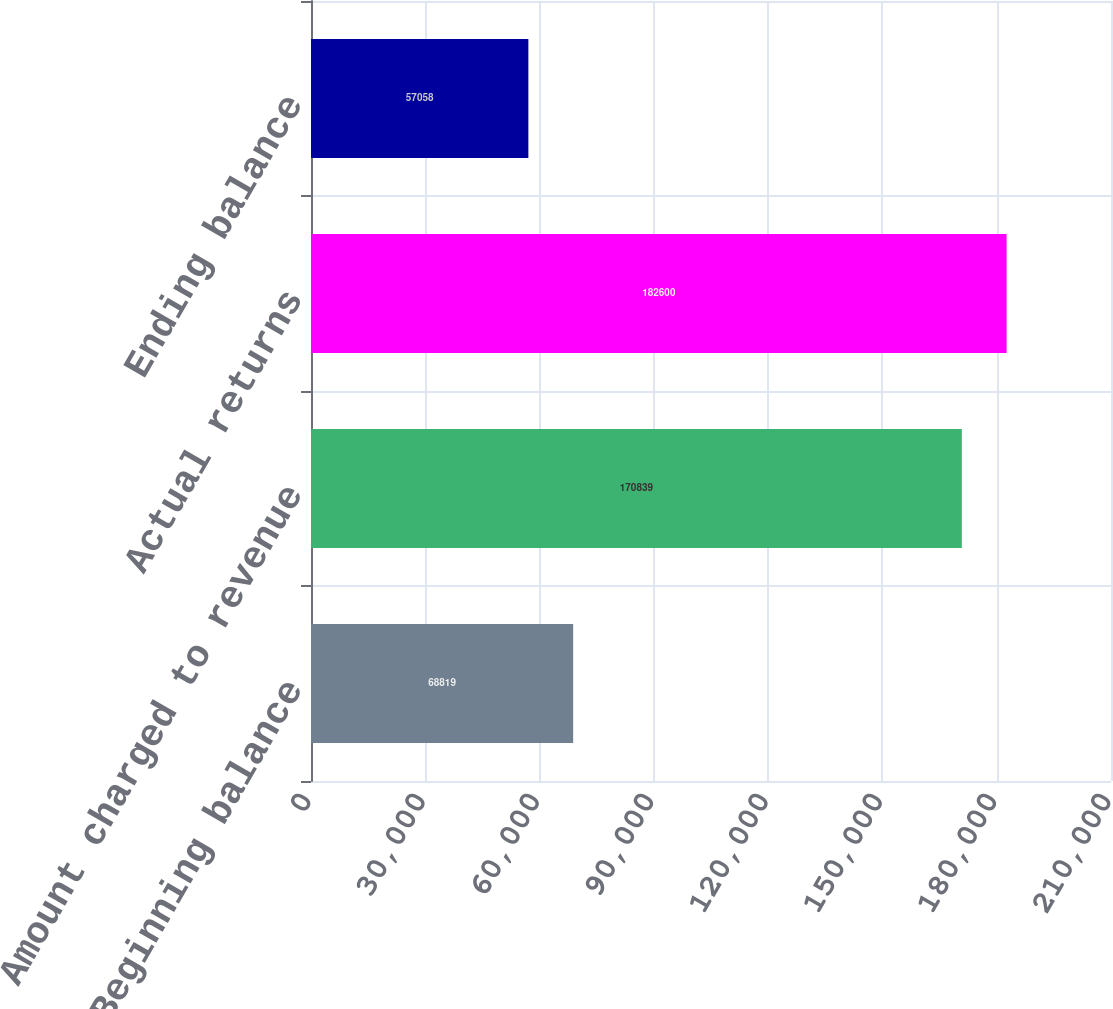<chart> <loc_0><loc_0><loc_500><loc_500><bar_chart><fcel>Beginning balance<fcel>Amount charged to revenue<fcel>Actual returns<fcel>Ending balance<nl><fcel>68819<fcel>170839<fcel>182600<fcel>57058<nl></chart> 